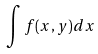Convert formula to latex. <formula><loc_0><loc_0><loc_500><loc_500>\int f ( x , y ) d x</formula> 